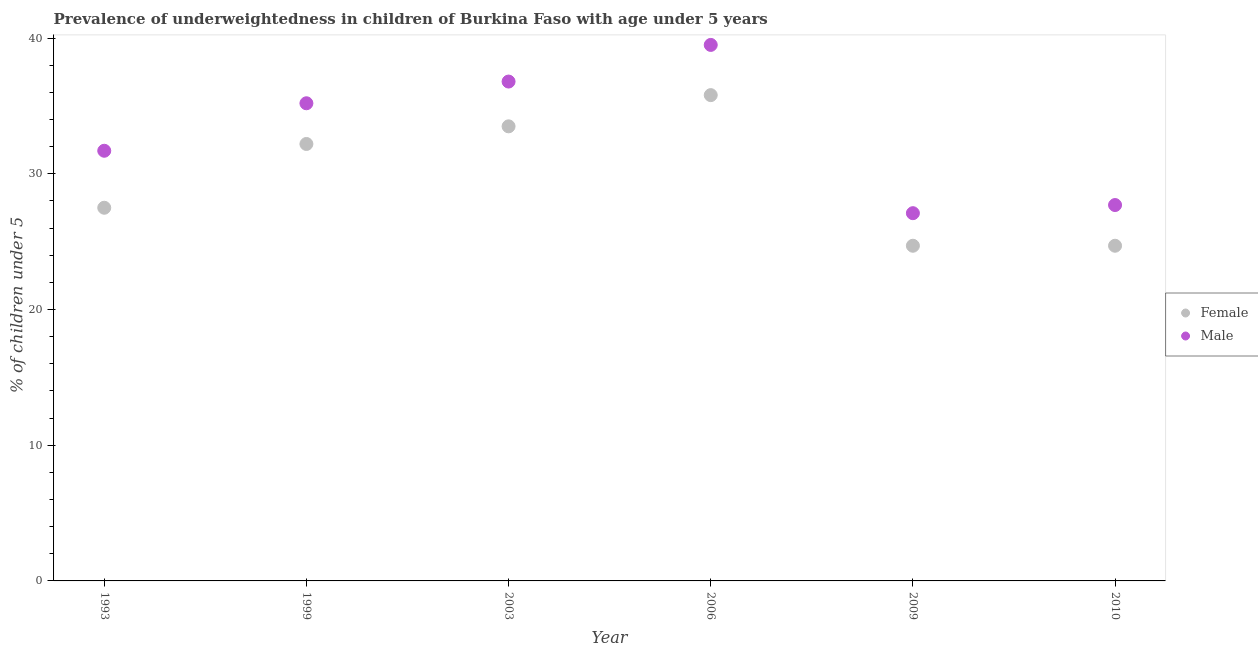Is the number of dotlines equal to the number of legend labels?
Offer a very short reply. Yes. What is the percentage of underweighted male children in 1993?
Keep it short and to the point. 31.7. Across all years, what is the maximum percentage of underweighted male children?
Ensure brevity in your answer.  39.5. Across all years, what is the minimum percentage of underweighted male children?
Offer a very short reply. 27.1. What is the total percentage of underweighted female children in the graph?
Give a very brief answer. 178.4. What is the difference between the percentage of underweighted male children in 1993 and that in 2006?
Your response must be concise. -7.8. What is the difference between the percentage of underweighted male children in 2010 and the percentage of underweighted female children in 2006?
Provide a succinct answer. -8.1. What is the average percentage of underweighted female children per year?
Give a very brief answer. 29.73. In the year 2010, what is the difference between the percentage of underweighted male children and percentage of underweighted female children?
Provide a short and direct response. 3. What is the ratio of the percentage of underweighted female children in 1999 to that in 2006?
Your response must be concise. 0.9. Is the percentage of underweighted female children in 1993 less than that in 1999?
Make the answer very short. Yes. Is the difference between the percentage of underweighted female children in 1993 and 2010 greater than the difference between the percentage of underweighted male children in 1993 and 2010?
Your answer should be compact. No. What is the difference between the highest and the second highest percentage of underweighted female children?
Ensure brevity in your answer.  2.3. What is the difference between the highest and the lowest percentage of underweighted male children?
Offer a terse response. 12.4. Does the percentage of underweighted male children monotonically increase over the years?
Give a very brief answer. No. How many dotlines are there?
Your answer should be compact. 2. How many years are there in the graph?
Provide a succinct answer. 6. What is the difference between two consecutive major ticks on the Y-axis?
Provide a succinct answer. 10. Does the graph contain grids?
Ensure brevity in your answer.  No. Where does the legend appear in the graph?
Keep it short and to the point. Center right. What is the title of the graph?
Your response must be concise. Prevalence of underweightedness in children of Burkina Faso with age under 5 years. What is the label or title of the Y-axis?
Your answer should be very brief.  % of children under 5. What is the  % of children under 5 of Female in 1993?
Your answer should be compact. 27.5. What is the  % of children under 5 of Male in 1993?
Provide a succinct answer. 31.7. What is the  % of children under 5 in Female in 1999?
Keep it short and to the point. 32.2. What is the  % of children under 5 in Male in 1999?
Your answer should be compact. 35.2. What is the  % of children under 5 in Female in 2003?
Offer a terse response. 33.5. What is the  % of children under 5 in Male in 2003?
Your answer should be compact. 36.8. What is the  % of children under 5 of Female in 2006?
Ensure brevity in your answer.  35.8. What is the  % of children under 5 of Male in 2006?
Your response must be concise. 39.5. What is the  % of children under 5 of Female in 2009?
Provide a succinct answer. 24.7. What is the  % of children under 5 of Male in 2009?
Offer a terse response. 27.1. What is the  % of children under 5 in Female in 2010?
Provide a succinct answer. 24.7. What is the  % of children under 5 of Male in 2010?
Offer a very short reply. 27.7. Across all years, what is the maximum  % of children under 5 in Female?
Keep it short and to the point. 35.8. Across all years, what is the maximum  % of children under 5 of Male?
Make the answer very short. 39.5. Across all years, what is the minimum  % of children under 5 of Female?
Offer a very short reply. 24.7. Across all years, what is the minimum  % of children under 5 in Male?
Make the answer very short. 27.1. What is the total  % of children under 5 in Female in the graph?
Provide a succinct answer. 178.4. What is the total  % of children under 5 of Male in the graph?
Your response must be concise. 198. What is the difference between the  % of children under 5 of Male in 1993 and that in 2003?
Provide a succinct answer. -5.1. What is the difference between the  % of children under 5 in Female in 1993 and that in 2006?
Keep it short and to the point. -8.3. What is the difference between the  % of children under 5 in Male in 1993 and that in 2006?
Provide a short and direct response. -7.8. What is the difference between the  % of children under 5 of Male in 1993 and that in 2009?
Your answer should be compact. 4.6. What is the difference between the  % of children under 5 in Male in 1999 and that in 2006?
Keep it short and to the point. -4.3. What is the difference between the  % of children under 5 of Female in 1999 and that in 2010?
Provide a succinct answer. 7.5. What is the difference between the  % of children under 5 in Male in 2003 and that in 2009?
Make the answer very short. 9.7. What is the difference between the  % of children under 5 of Male in 2003 and that in 2010?
Ensure brevity in your answer.  9.1. What is the difference between the  % of children under 5 of Female in 2006 and that in 2009?
Offer a terse response. 11.1. What is the difference between the  % of children under 5 of Female in 2006 and that in 2010?
Give a very brief answer. 11.1. What is the difference between the  % of children under 5 of Male in 2006 and that in 2010?
Your answer should be very brief. 11.8. What is the difference between the  % of children under 5 in Male in 2009 and that in 2010?
Give a very brief answer. -0.6. What is the difference between the  % of children under 5 of Female in 1993 and the  % of children under 5 of Male in 1999?
Your answer should be compact. -7.7. What is the difference between the  % of children under 5 of Female in 1993 and the  % of children under 5 of Male in 2009?
Provide a succinct answer. 0.4. What is the difference between the  % of children under 5 in Female in 1999 and the  % of children under 5 in Male in 2006?
Ensure brevity in your answer.  -7.3. What is the difference between the  % of children under 5 in Female in 1999 and the  % of children under 5 in Male in 2009?
Keep it short and to the point. 5.1. What is the difference between the  % of children under 5 in Female in 1999 and the  % of children under 5 in Male in 2010?
Your response must be concise. 4.5. What is the difference between the  % of children under 5 of Female in 2003 and the  % of children under 5 of Male in 2009?
Offer a terse response. 6.4. What is the difference between the  % of children under 5 of Female in 2006 and the  % of children under 5 of Male in 2009?
Your answer should be compact. 8.7. What is the difference between the  % of children under 5 in Female in 2006 and the  % of children under 5 in Male in 2010?
Make the answer very short. 8.1. What is the average  % of children under 5 of Female per year?
Ensure brevity in your answer.  29.73. In the year 1993, what is the difference between the  % of children under 5 of Female and  % of children under 5 of Male?
Ensure brevity in your answer.  -4.2. In the year 1999, what is the difference between the  % of children under 5 of Female and  % of children under 5 of Male?
Keep it short and to the point. -3. In the year 2003, what is the difference between the  % of children under 5 of Female and  % of children under 5 of Male?
Keep it short and to the point. -3.3. In the year 2006, what is the difference between the  % of children under 5 in Female and  % of children under 5 in Male?
Make the answer very short. -3.7. In the year 2009, what is the difference between the  % of children under 5 in Female and  % of children under 5 in Male?
Your response must be concise. -2.4. What is the ratio of the  % of children under 5 of Female in 1993 to that in 1999?
Your answer should be compact. 0.85. What is the ratio of the  % of children under 5 of Male in 1993 to that in 1999?
Make the answer very short. 0.9. What is the ratio of the  % of children under 5 of Female in 1993 to that in 2003?
Provide a succinct answer. 0.82. What is the ratio of the  % of children under 5 in Male in 1993 to that in 2003?
Your answer should be compact. 0.86. What is the ratio of the  % of children under 5 in Female in 1993 to that in 2006?
Offer a terse response. 0.77. What is the ratio of the  % of children under 5 of Male in 1993 to that in 2006?
Ensure brevity in your answer.  0.8. What is the ratio of the  % of children under 5 of Female in 1993 to that in 2009?
Provide a short and direct response. 1.11. What is the ratio of the  % of children under 5 in Male in 1993 to that in 2009?
Your response must be concise. 1.17. What is the ratio of the  % of children under 5 in Female in 1993 to that in 2010?
Give a very brief answer. 1.11. What is the ratio of the  % of children under 5 of Male in 1993 to that in 2010?
Your answer should be very brief. 1.14. What is the ratio of the  % of children under 5 of Female in 1999 to that in 2003?
Your response must be concise. 0.96. What is the ratio of the  % of children under 5 of Male in 1999 to that in 2003?
Provide a short and direct response. 0.96. What is the ratio of the  % of children under 5 in Female in 1999 to that in 2006?
Your answer should be compact. 0.9. What is the ratio of the  % of children under 5 in Male in 1999 to that in 2006?
Make the answer very short. 0.89. What is the ratio of the  % of children under 5 in Female in 1999 to that in 2009?
Provide a short and direct response. 1.3. What is the ratio of the  % of children under 5 of Male in 1999 to that in 2009?
Make the answer very short. 1.3. What is the ratio of the  % of children under 5 in Female in 1999 to that in 2010?
Your response must be concise. 1.3. What is the ratio of the  % of children under 5 of Male in 1999 to that in 2010?
Your answer should be compact. 1.27. What is the ratio of the  % of children under 5 of Female in 2003 to that in 2006?
Your answer should be compact. 0.94. What is the ratio of the  % of children under 5 in Male in 2003 to that in 2006?
Your answer should be compact. 0.93. What is the ratio of the  % of children under 5 in Female in 2003 to that in 2009?
Your answer should be very brief. 1.36. What is the ratio of the  % of children under 5 of Male in 2003 to that in 2009?
Provide a succinct answer. 1.36. What is the ratio of the  % of children under 5 in Female in 2003 to that in 2010?
Your answer should be very brief. 1.36. What is the ratio of the  % of children under 5 in Male in 2003 to that in 2010?
Make the answer very short. 1.33. What is the ratio of the  % of children under 5 in Female in 2006 to that in 2009?
Keep it short and to the point. 1.45. What is the ratio of the  % of children under 5 of Male in 2006 to that in 2009?
Your response must be concise. 1.46. What is the ratio of the  % of children under 5 in Female in 2006 to that in 2010?
Provide a short and direct response. 1.45. What is the ratio of the  % of children under 5 in Male in 2006 to that in 2010?
Offer a terse response. 1.43. What is the ratio of the  % of children under 5 in Female in 2009 to that in 2010?
Give a very brief answer. 1. What is the ratio of the  % of children under 5 of Male in 2009 to that in 2010?
Offer a very short reply. 0.98. What is the difference between the highest and the lowest  % of children under 5 in Female?
Make the answer very short. 11.1. What is the difference between the highest and the lowest  % of children under 5 in Male?
Keep it short and to the point. 12.4. 